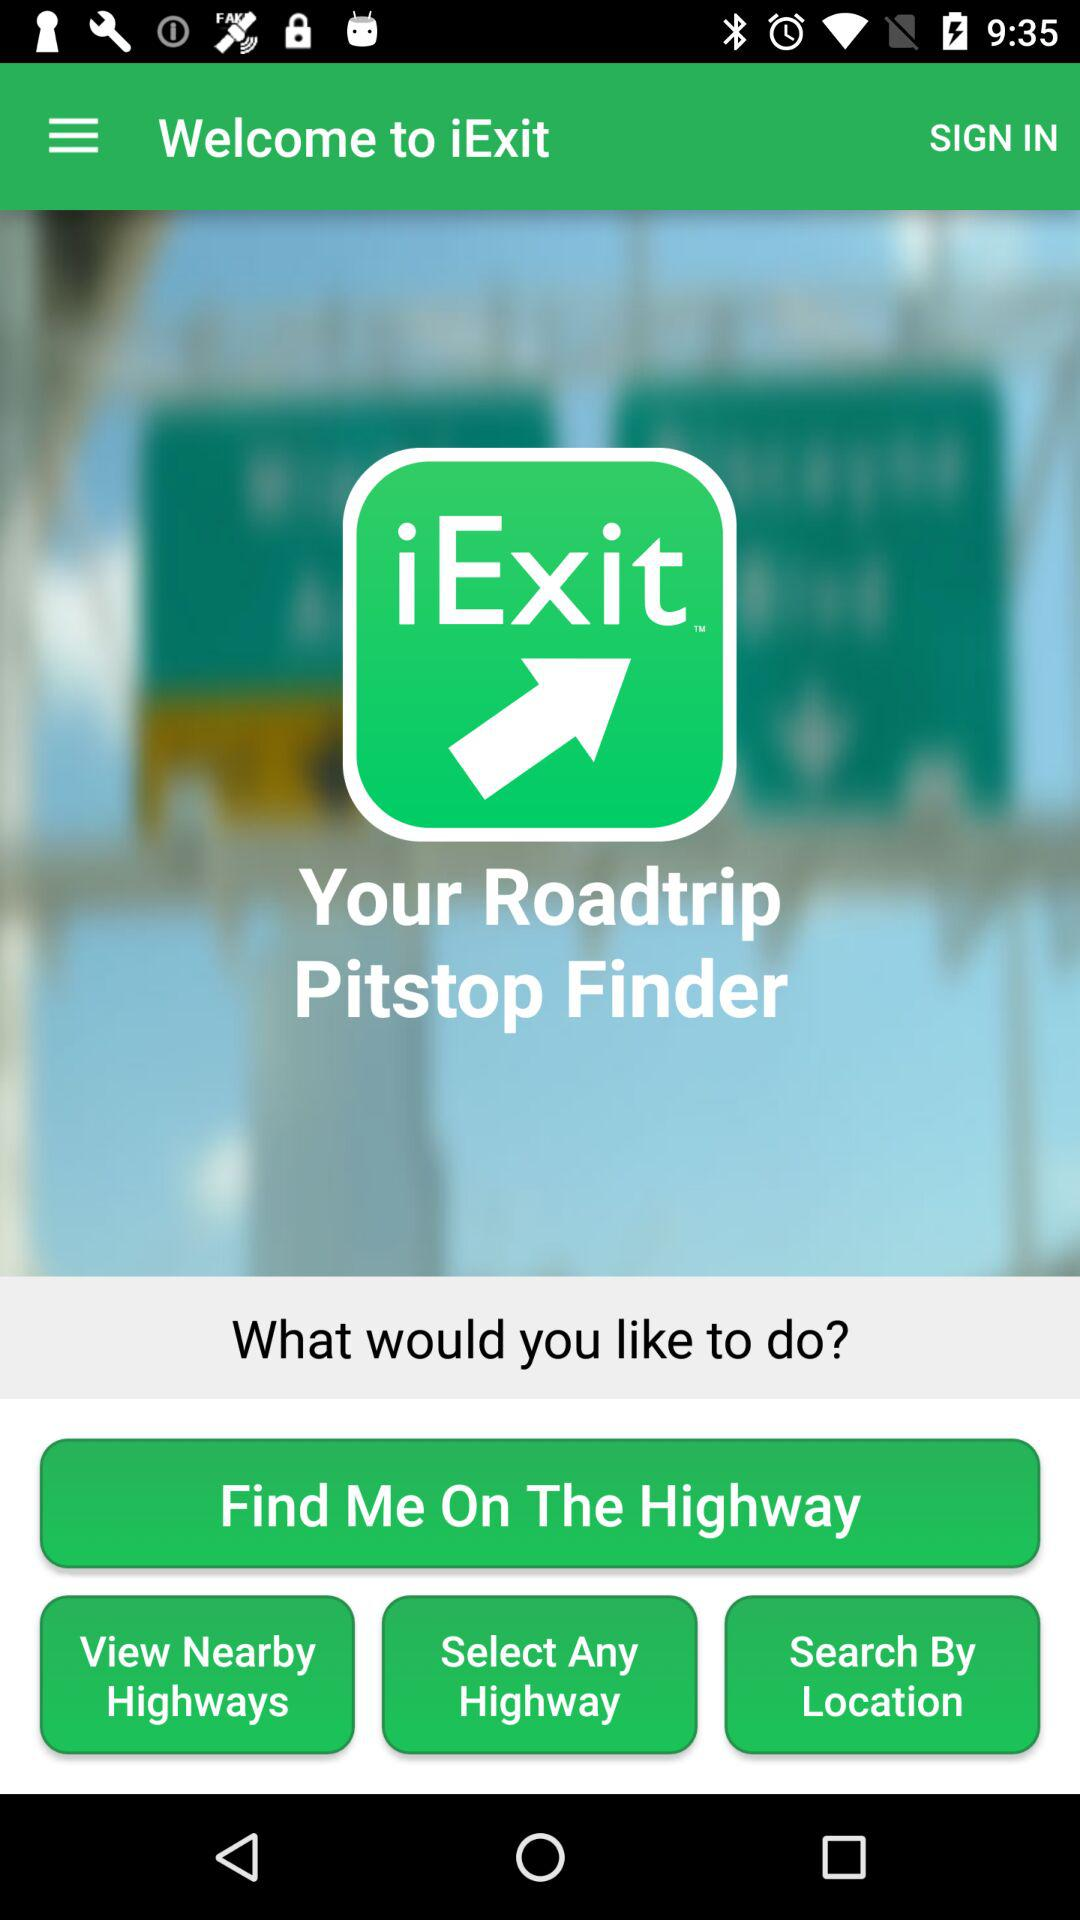What is the app name? The app name is "iExit Interstate Exit Guide". 